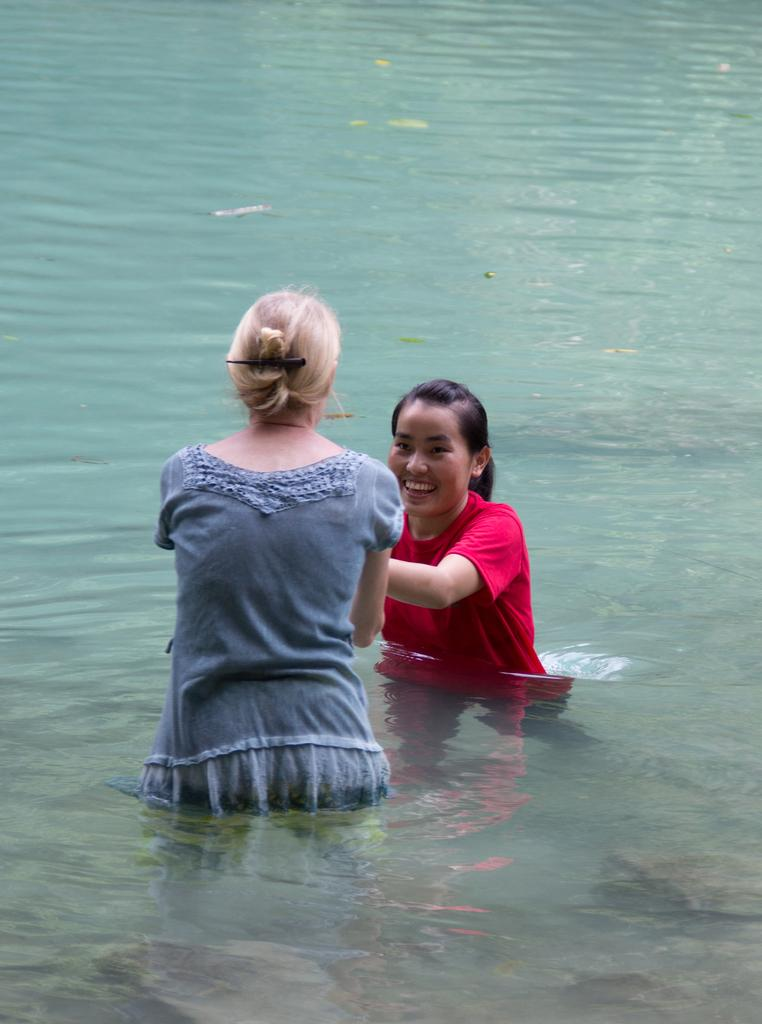How many women are in the image? There are two women in the image. What colors are the dresses of the women? One woman is wearing a red color dress, and the other woman is wearing a grey color dress. Where are the women located in the image? Both women are in the water. What type of scent can be detected from the women's shoes in the image? There is no mention of shoes in the image, so it is not possible to determine any scent associated with them. 